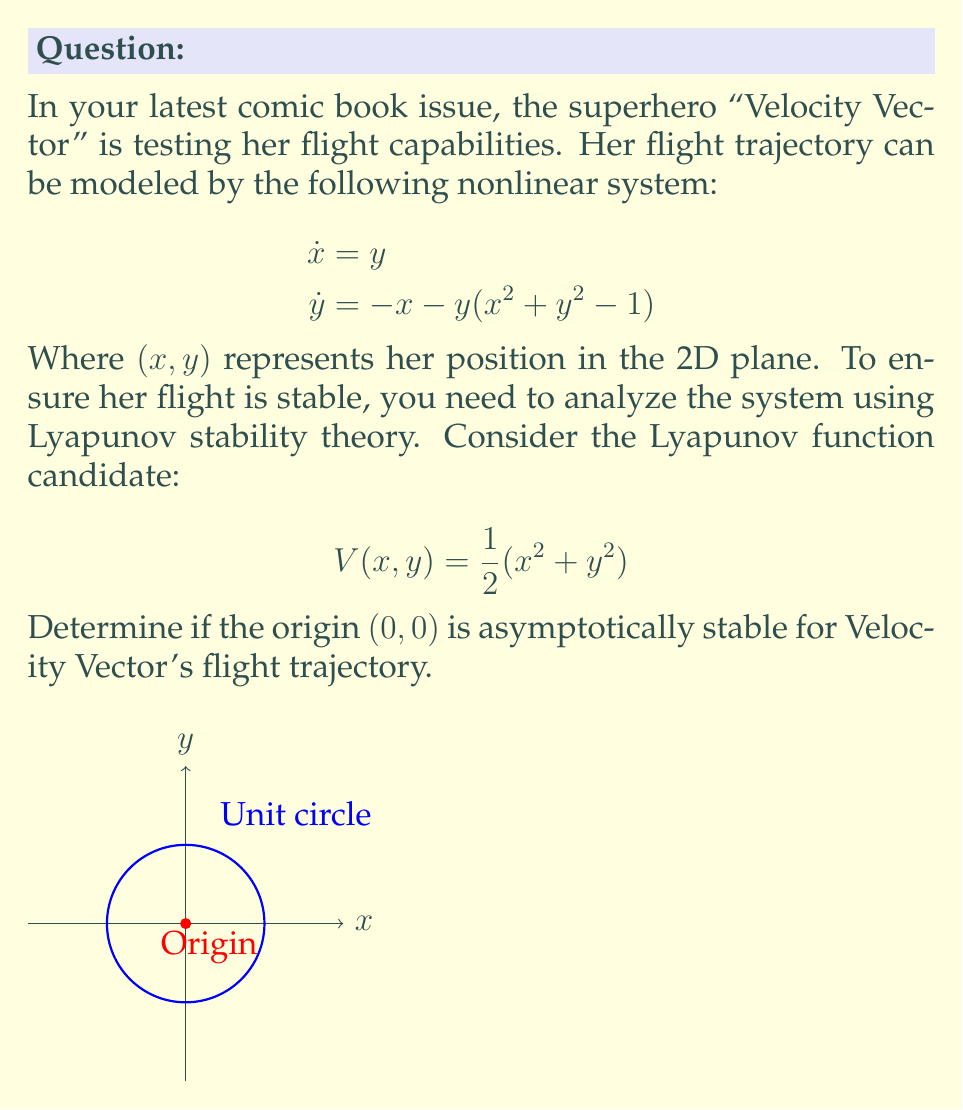Give your solution to this math problem. To analyze the stability of the origin using Lyapunov stability theory, we need to check if the Lyapunov function $V(x, y)$ satisfies the following conditions:

1. $V(0, 0) = 0$
2. $V(x, y) > 0$ for all $(x, y) \neq (0, 0)$
3. $\dot{V}(x, y) < 0$ for all $(x, y) \neq (0, 0)$

Step 1: Check the first two conditions
- $V(0, 0) = \frac{1}{2}(0^2 + 0^2) = 0$
- $V(x, y) = \frac{1}{2}(x^2 + y^2) > 0$ for all $(x, y) \neq (0, 0)$

The first two conditions are satisfied.

Step 2: Calculate $\dot{V}(x, y)$
$$\begin{aligned}
\dot{V}(x, y) &= \frac{\partial V}{\partial x}\dot{x} + \frac{\partial V}{\partial y}\dot{y} \\
&= x\dot{x} + y\dot{y} \\
&= xy + y[-x - y(x^2 + y^2 - 1)] \\
&= xy - xy - y^2(x^2 + y^2 - 1) \\
&= -y^2(x^2 + y^2 - 1)
\end{aligned}$$

Step 3: Analyze $\dot{V}(x, y)$
- Inside the unit circle $(x^2 + y^2 < 1)$: $\dot{V}(x, y) < 0$
- On the unit circle $(x^2 + y^2 = 1)$: $\dot{V}(x, y) = 0$
- Outside the unit circle $(x^2 + y^2 > 1)$: $\dot{V}(x, y) > 0$

Step 4: Conclusion
The Lyapunov function doesn't strictly satisfy the third condition for all $(x, y) \neq (0, 0)$. However, it does show that trajectories inside the unit circle will converge to the origin, while trajectories outside the unit circle will approach the unit circle.

This system exhibits a limit cycle behavior on the unit circle. The origin is asymptotically stable for all initial conditions inside the unit circle, but it is not globally asymptotically stable.
Answer: The origin is locally asymptotically stable within the unit circle. 